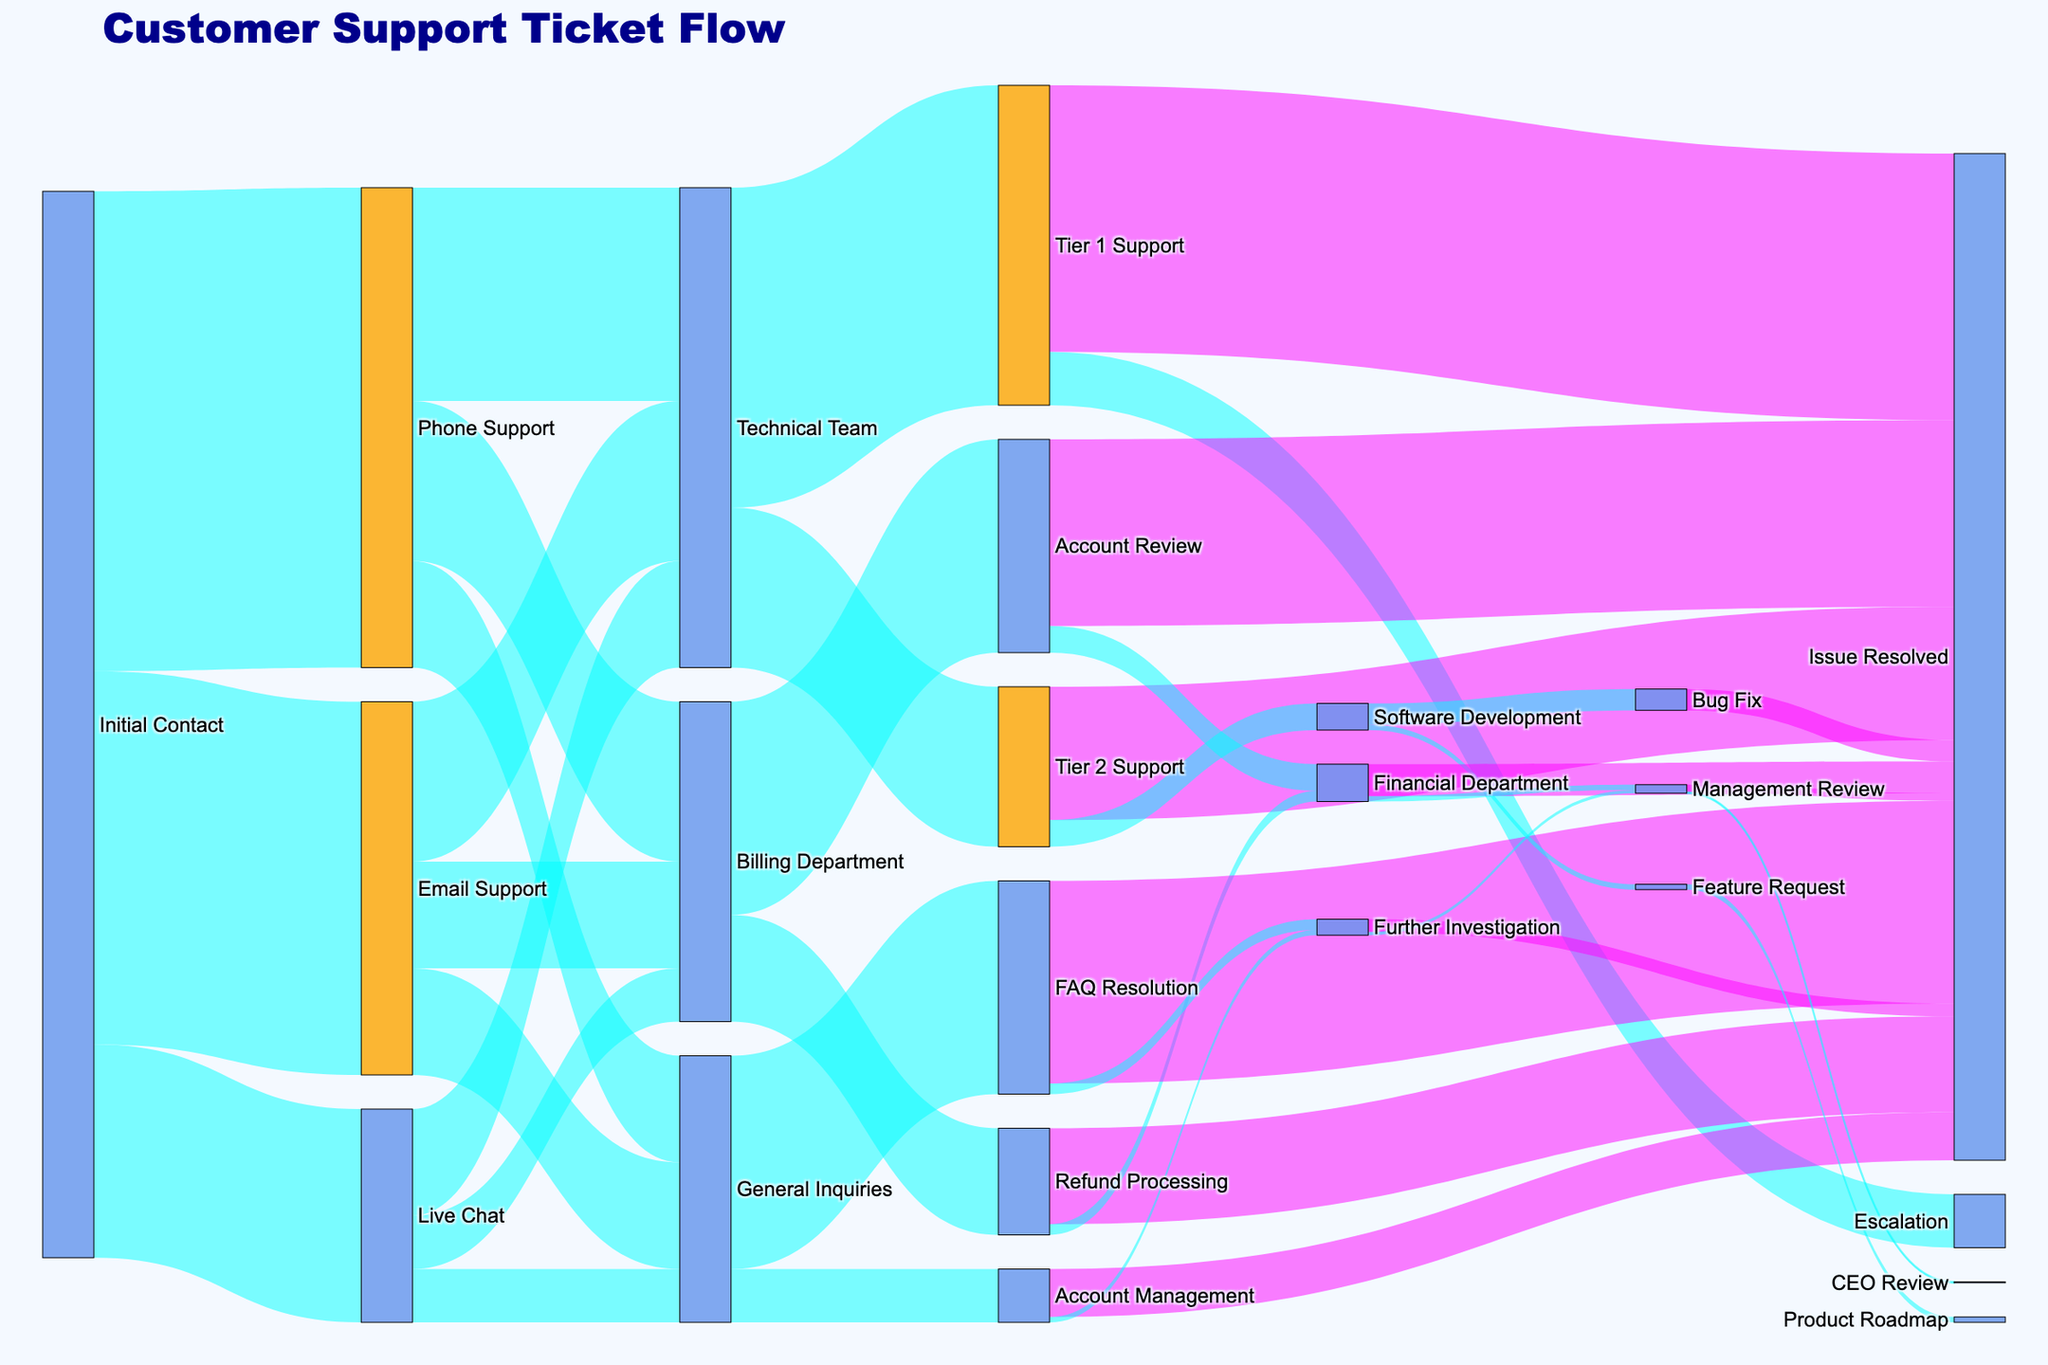What is the title of the diagram? The title of the diagram is located at the top and provides a summary of what the figure is about. It states "Customer Support Ticket Flow."
Answer: Customer Support Ticket Flow How many tickets reached the Technical Team from Email Support? To find this, look at the flow from "Email Support" to "Technical Team," which shows the number of tickets. The value given is 150.
Answer: 150 Which channel had the highest number of initial contacts? This can be determined by comparing the values for "Email Support," "Phone Support," and "Live Chat" from "Initial Contact." "Phone Support" has the highest value at 450.
Answer: Phone Support What are the different departments involved after the initial contact? Departments can be identified by the number of targets coming from the nodes. After initial contact, the departments involved are "Email Support," "Phone Support," and "Live Chat."
Answer: Email Support, Phone Support, Live Chat How many tickets were resolved by Tier 1 Support? Find the flow from "Tier 1 Support" to "Issue Resolved." The value given is 250.
Answer: 250 How many tickets were managed by the Billing Department in total? Sum all values going to the "Billing Department" from all sources (Email Support, Phone Support, Live Chat). The values are 100, 150, and 50, respectively. The total is 100 + 150 + 50 = 300.
Answer: 300 What is the total number of tickets that required further investigation? Add up all the values that lead to "Further Investigation." From the diagram, "FAQ Resolution" to "Further Investigation" has 10, and "Account Management" to "Further Investigation" has 5. Totals: 10 + 5 = 15.
Answer: 15 Which step resolves the fewest tickets directly? Compare all the nodes leading to "Issue Resolved" and find the one with the lowest value. "Financial Department" to "Issue Resolved" has 30, which is the smallest among them.
Answer: Financial Department How many tickets reached the CEO Review stage? Look for the flow going to "CEO Review." From "Management Review" to "CEO Review," the value is 1.
Answer: 1 Which team has the most escalations? Look at the nodes leading to "Escalation." "Tier 1 Support" to "Escalation" has a value of 50. There is no other node leading to "Escalation."
Answer: Tier 1 Support 